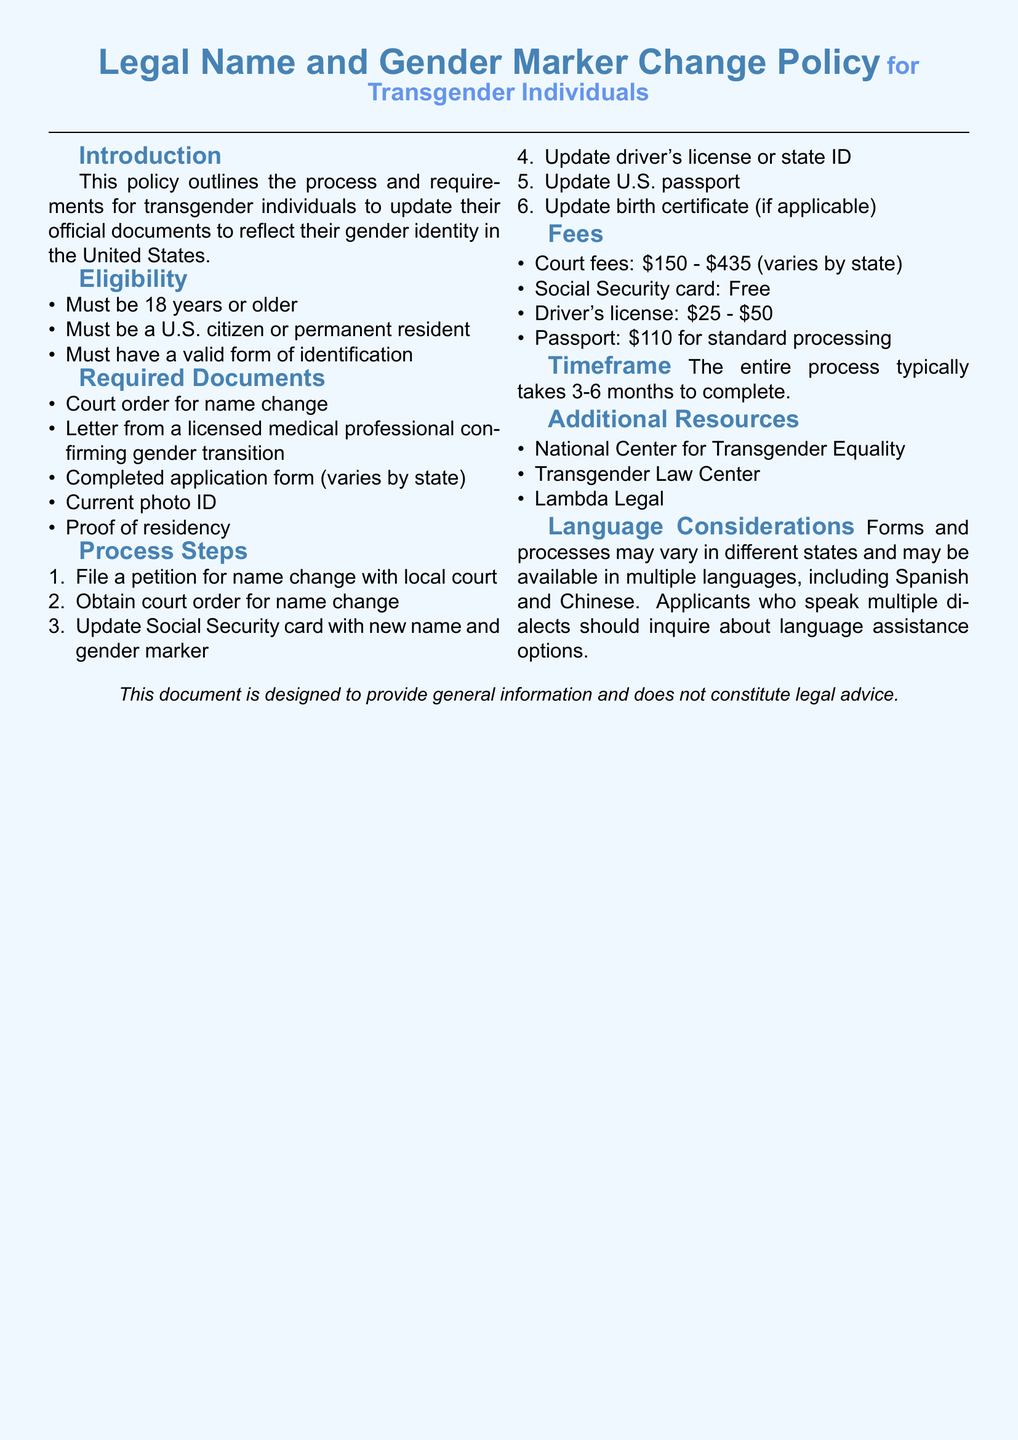What is the age requirement to change legal name and gender marker? The policy states that applicants must be 18 years or older.
Answer: 18 years What is one required document for a name change? A court order for name change is listed as one of the required documents.
Answer: Court order for name change How much does a driver's license update typically cost? The document specifies that the cost for updating a driver's license ranges from $25 to $50.
Answer: $25 - $50 What is the timeframe for completing the entire process? The document mentions that the entire process typically takes 3-6 months to complete.
Answer: 3-6 months Which organization is listed as an additional resource for transgender individuals? The National Center for Transgender Equality is mentioned as an additional resource.
Answer: National Center for Transgender Equality How many steps are in the process to change legal name and gender marker? The process steps section contains a list of 6 steps for the name change process.
Answer: 6 steps What is the fee range for court fees related to name change? The document indicates that court fees vary from $150 to $435.
Answer: $150 - $435 What should applicants inquire about if they speak multiple dialects? The policy suggests applicants should inquire about language assistance options.
Answer: Language assistance options 